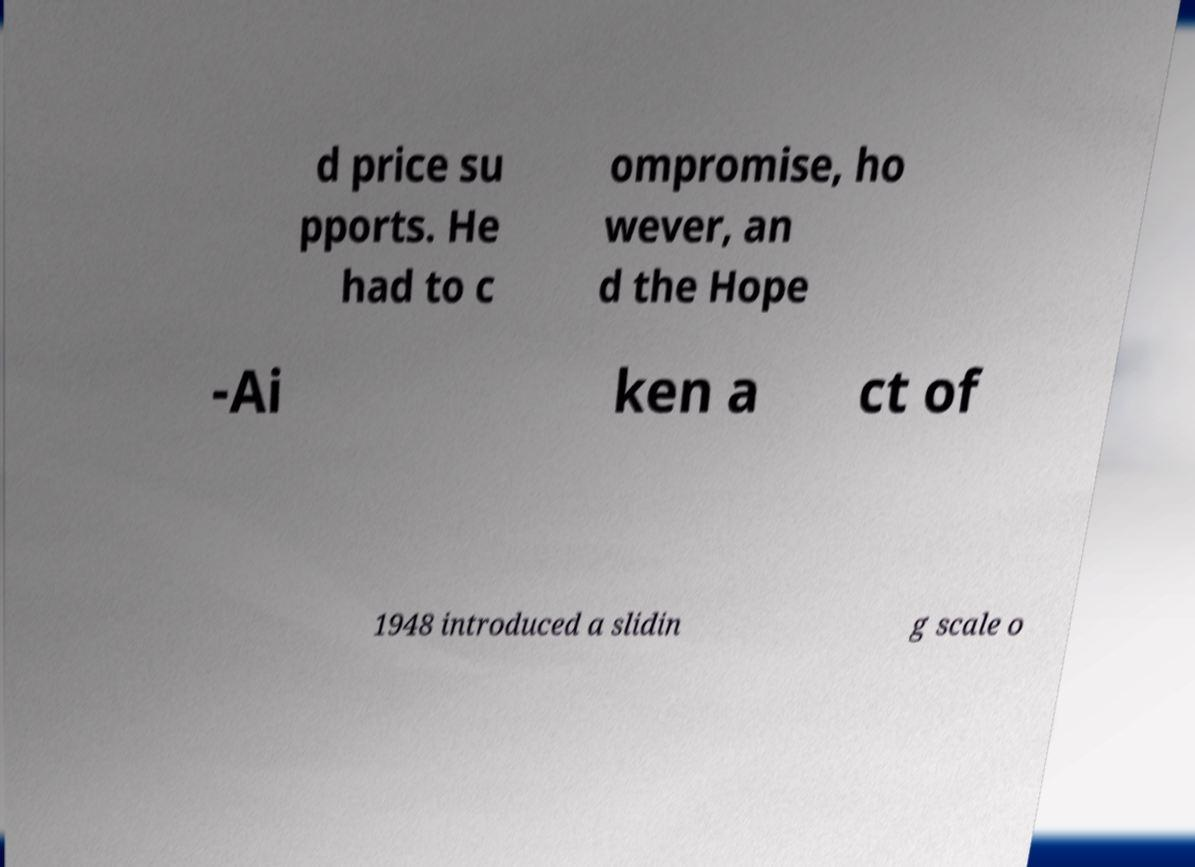Please identify and transcribe the text found in this image. d price su pports. He had to c ompromise, ho wever, an d the Hope -Ai ken a ct of 1948 introduced a slidin g scale o 